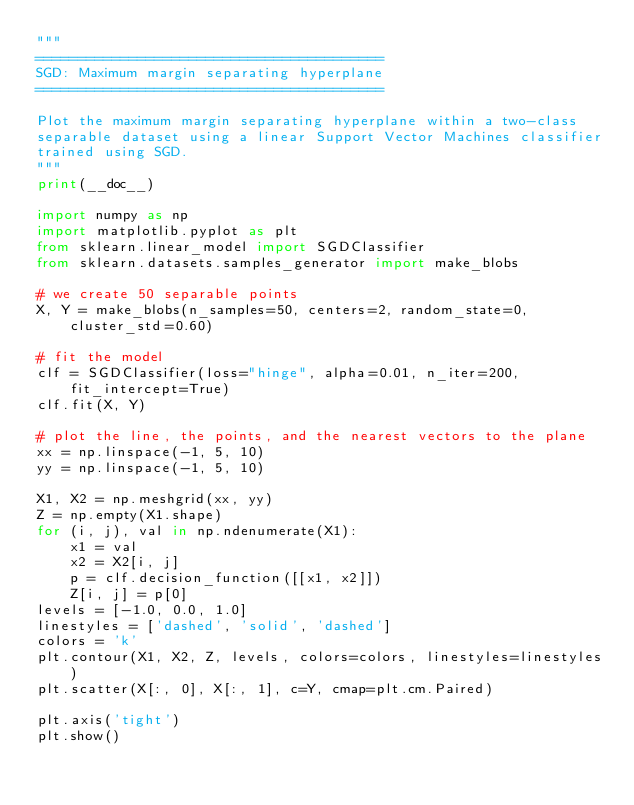Convert code to text. <code><loc_0><loc_0><loc_500><loc_500><_Python_>"""
=========================================
SGD: Maximum margin separating hyperplane
=========================================

Plot the maximum margin separating hyperplane within a two-class
separable dataset using a linear Support Vector Machines classifier
trained using SGD.
"""
print(__doc__)

import numpy as np
import matplotlib.pyplot as plt
from sklearn.linear_model import SGDClassifier
from sklearn.datasets.samples_generator import make_blobs

# we create 50 separable points
X, Y = make_blobs(n_samples=50, centers=2, random_state=0, cluster_std=0.60)

# fit the model
clf = SGDClassifier(loss="hinge", alpha=0.01, n_iter=200, fit_intercept=True)
clf.fit(X, Y)

# plot the line, the points, and the nearest vectors to the plane
xx = np.linspace(-1, 5, 10)
yy = np.linspace(-1, 5, 10)

X1, X2 = np.meshgrid(xx, yy)
Z = np.empty(X1.shape)
for (i, j), val in np.ndenumerate(X1):
    x1 = val
    x2 = X2[i, j]
    p = clf.decision_function([[x1, x2]])
    Z[i, j] = p[0]
levels = [-1.0, 0.0, 1.0]
linestyles = ['dashed', 'solid', 'dashed']
colors = 'k'
plt.contour(X1, X2, Z, levels, colors=colors, linestyles=linestyles)
plt.scatter(X[:, 0], X[:, 1], c=Y, cmap=plt.cm.Paired)

plt.axis('tight')
plt.show()
</code> 